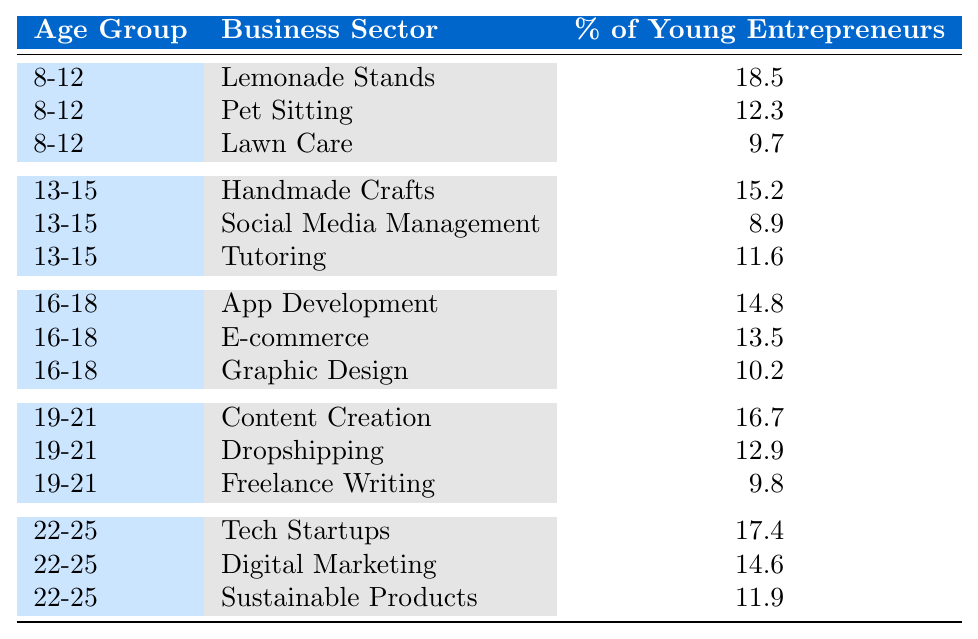What is the highest percentage of young entrepreneurs in the age group 8-12? From the data, the percentages for the age group 8-12 are: Lemonade Stands (18.5), Pet Sitting (12.3), and Lawn Care (9.7). The highest percentage is clearly 18.5 from Lemonade Stands.
Answer: 18.5 Which business sector has the lowest percentage of young entrepreneurs in the age group 16-18? The business sectors for the age group 16-18 are: App Development (14.8), E-commerce (13.5), and Graphic Design (10.2). The lowest percentage here is 10.2 from Graphic Design.
Answer: 10.2 What percentage of young entrepreneurs aged 19-21 is involved in Dropshipping? Looking at the age group 19-21, the percentage for Dropshipping is listed as 12.9.
Answer: 12.9 What is the average percentage of young entrepreneurs for the age group 22-25? For age group 22-25, the percentages are 17.4 (Tech Startups), 14.6 (Digital Marketing), and 11.9 (Sustainable Products). Summing these gives us 17.4 + 14.6 + 11.9 = 43.9. There are 3 sectors, so the average is 43.9 / 3 = 14.63.
Answer: 14.63 Is the percentage of young entrepreneurs in Pet Sitting higher than in Social Media Management? Pet Sitting has a percentage of 12.3, whereas Social Media Management has 8.9. Since 12.3 is greater than 8.9, the statement is true.
Answer: Yes Which age group has the most varied (spread out) percentage of business sectors in the table? To find which age group is most varied, we can look at the highest and lowest percentages for each group: 8-12 (18.5 to 9.7 gives a range of 8.8), 13-15 (15.2 to 8.9 gives a range of 6.3), 16-18 (14.8 to 10.2 gives a range of 4.6), 19-21 (16.7 to 9.8 gives a range of 6.9), and 22-25 (17.4 to 11.9 gives a range of 5.5). The age group 8-12 has the largest range of 8.8, indicating it is the most varied.
Answer: 8-12 How many percentages are above 15% in the sector "Content Creation"? In the age group 19-21, Content Creation has a percentage of 16.7, which is above 15%. Thus, only this sector from the mentioned age group qualifies.
Answer: 1 Does the E-commerce sector have a higher percentage compared to Freelance Writing? E-commerce has a percentage of 13.5 while Freelance Writing has a percentage of 9.8. Since 13.5 is greater than 9.8, E-commerce has a higher percentage.
Answer: Yes What is the total percentage of young entrepreneurs involved in "Handmade Crafts" and "Lawn Care"? Handmade Crafts has a percentage of 15.2 and Lawn Care has 9.7. So, the total is 15.2 + 9.7 = 24.9.
Answer: 24.9 Which age group has the highest percentage of young entrepreneurs participating in Tech Startups? Tech Startups has a specific mention under the age group 22-25, with a percentage of 17.4. This is the only percentage for Tech Startups, making 22-25 the group with the highest percentage for that sector.
Answer: 22-25 